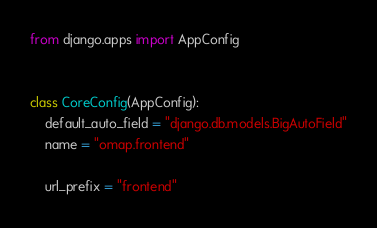Convert code to text. <code><loc_0><loc_0><loc_500><loc_500><_Python_>from django.apps import AppConfig


class CoreConfig(AppConfig):
    default_auto_field = "django.db.models.BigAutoField"
    name = "omap.frontend"

    url_prefix = "frontend"
</code> 